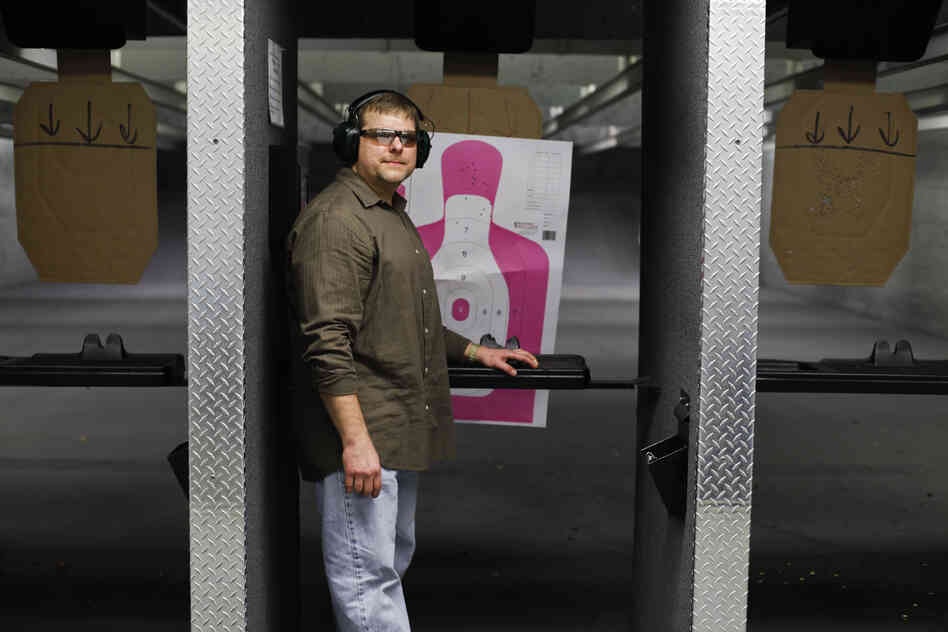If this shooting range were part of a movie scene, what kind of storyline would fit? In a movie setting, this shooting range could be the backdrop for a high-stakes espionage thriller. The protagonist, an undercover agent, uses the range to hone their shooting skills in preparation for a critical mission. The tension builds as they receive intel about a planned sabotage within the range itself, leading to a dramatic chase and shootout.

Alternatively, the range could serve as a training ground for a group of elite operatives preparing for a rescue mission. The storyline could follow their rigorous training sessions, showcasing their growth as a team and highlighting their individual skills. The range's features, from precision targeting to tactical movement exercises, would play a crucial role in their mission's success, culminating in a high-energy climax as they put their training to the test. 